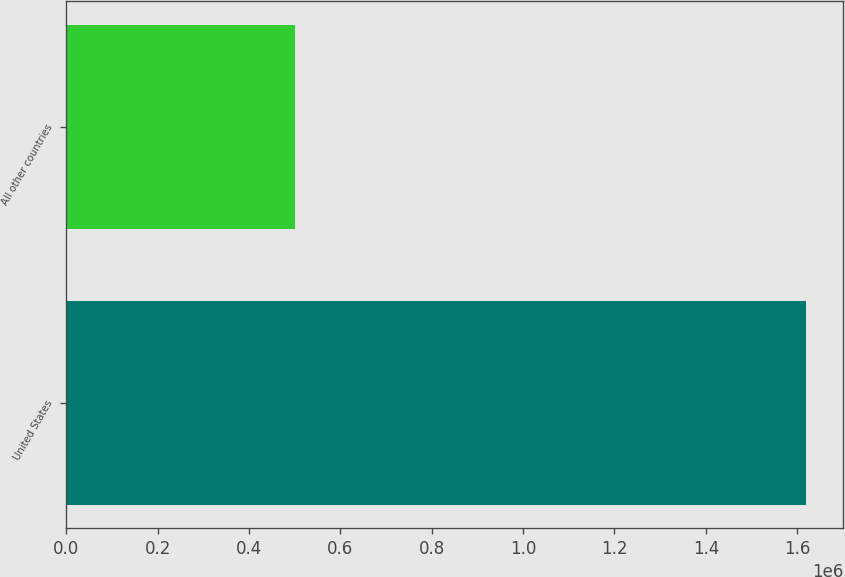<chart> <loc_0><loc_0><loc_500><loc_500><bar_chart><fcel>United States<fcel>All other countries<nl><fcel>1.6196e+06<fcel>499852<nl></chart> 